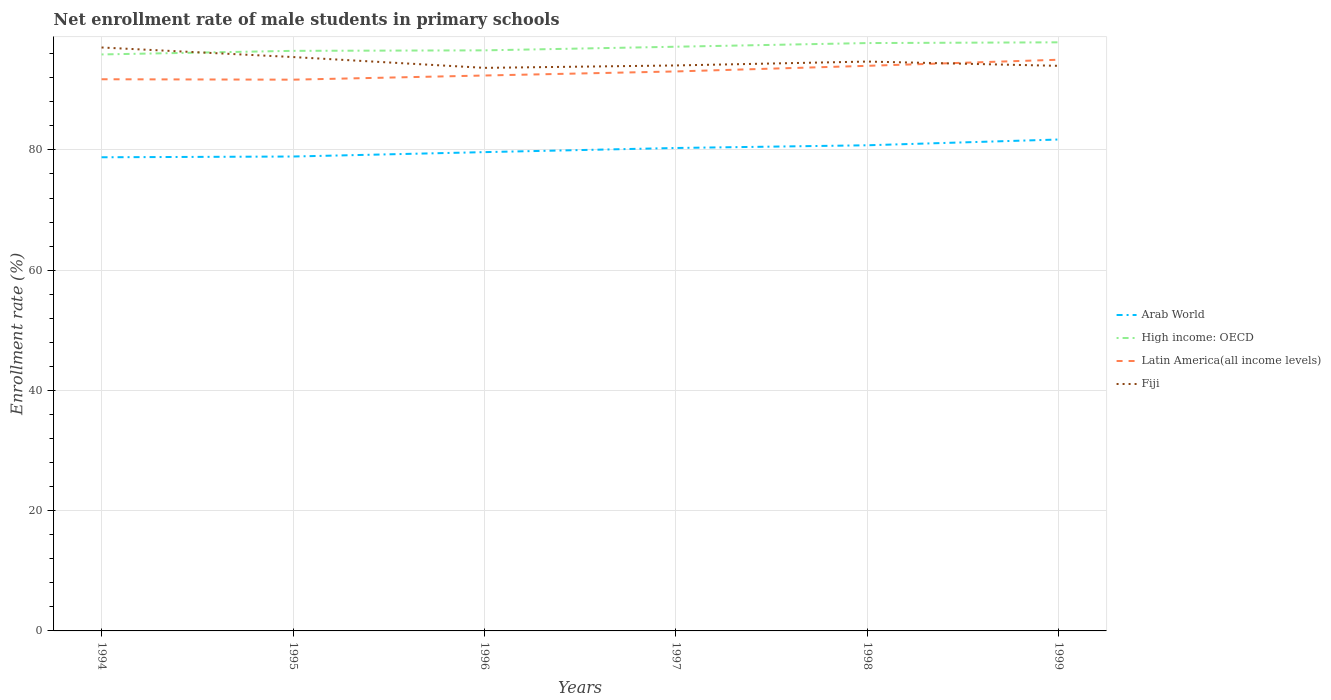How many different coloured lines are there?
Offer a very short reply. 4. Does the line corresponding to Fiji intersect with the line corresponding to High income: OECD?
Give a very brief answer. Yes. Across all years, what is the maximum net enrollment rate of male students in primary schools in High income: OECD?
Your answer should be compact. 95.88. What is the total net enrollment rate of male students in primary schools in High income: OECD in the graph?
Offer a terse response. -0.68. What is the difference between the highest and the second highest net enrollment rate of male students in primary schools in Arab World?
Your answer should be compact. 2.95. What is the difference between the highest and the lowest net enrollment rate of male students in primary schools in Arab World?
Ensure brevity in your answer.  3. Is the net enrollment rate of male students in primary schools in Latin America(all income levels) strictly greater than the net enrollment rate of male students in primary schools in Arab World over the years?
Give a very brief answer. No. How many lines are there?
Your answer should be compact. 4. How many years are there in the graph?
Provide a short and direct response. 6. What is the difference between two consecutive major ticks on the Y-axis?
Offer a terse response. 20. Does the graph contain any zero values?
Your answer should be very brief. No. How many legend labels are there?
Ensure brevity in your answer.  4. How are the legend labels stacked?
Your answer should be very brief. Vertical. What is the title of the graph?
Give a very brief answer. Net enrollment rate of male students in primary schools. Does "Egypt, Arab Rep." appear as one of the legend labels in the graph?
Give a very brief answer. No. What is the label or title of the Y-axis?
Ensure brevity in your answer.  Enrollment rate (%). What is the Enrollment rate (%) in Arab World in 1994?
Offer a terse response. 78.78. What is the Enrollment rate (%) of High income: OECD in 1994?
Your answer should be very brief. 95.88. What is the Enrollment rate (%) in Latin America(all income levels) in 1994?
Give a very brief answer. 91.76. What is the Enrollment rate (%) in Fiji in 1994?
Your answer should be very brief. 97.04. What is the Enrollment rate (%) in Arab World in 1995?
Your response must be concise. 78.91. What is the Enrollment rate (%) of High income: OECD in 1995?
Keep it short and to the point. 96.48. What is the Enrollment rate (%) in Latin America(all income levels) in 1995?
Offer a terse response. 91.69. What is the Enrollment rate (%) in Fiji in 1995?
Offer a very short reply. 95.45. What is the Enrollment rate (%) of Arab World in 1996?
Your answer should be compact. 79.64. What is the Enrollment rate (%) of High income: OECD in 1996?
Provide a succinct answer. 96.56. What is the Enrollment rate (%) of Latin America(all income levels) in 1996?
Keep it short and to the point. 92.38. What is the Enrollment rate (%) in Fiji in 1996?
Your answer should be very brief. 93.65. What is the Enrollment rate (%) of Arab World in 1997?
Offer a terse response. 80.33. What is the Enrollment rate (%) in High income: OECD in 1997?
Offer a terse response. 97.17. What is the Enrollment rate (%) in Latin America(all income levels) in 1997?
Your answer should be very brief. 93.06. What is the Enrollment rate (%) of Fiji in 1997?
Ensure brevity in your answer.  94.05. What is the Enrollment rate (%) in Arab World in 1998?
Your answer should be compact. 80.78. What is the Enrollment rate (%) in High income: OECD in 1998?
Make the answer very short. 97.78. What is the Enrollment rate (%) in Latin America(all income levels) in 1998?
Offer a terse response. 93.99. What is the Enrollment rate (%) in Fiji in 1998?
Keep it short and to the point. 94.7. What is the Enrollment rate (%) in Arab World in 1999?
Give a very brief answer. 81.74. What is the Enrollment rate (%) in High income: OECD in 1999?
Provide a succinct answer. 97.9. What is the Enrollment rate (%) of Latin America(all income levels) in 1999?
Give a very brief answer. 95. What is the Enrollment rate (%) of Fiji in 1999?
Give a very brief answer. 93.99. Across all years, what is the maximum Enrollment rate (%) in Arab World?
Give a very brief answer. 81.74. Across all years, what is the maximum Enrollment rate (%) in High income: OECD?
Your answer should be compact. 97.9. Across all years, what is the maximum Enrollment rate (%) in Latin America(all income levels)?
Offer a very short reply. 95. Across all years, what is the maximum Enrollment rate (%) in Fiji?
Ensure brevity in your answer.  97.04. Across all years, what is the minimum Enrollment rate (%) in Arab World?
Ensure brevity in your answer.  78.78. Across all years, what is the minimum Enrollment rate (%) of High income: OECD?
Offer a terse response. 95.88. Across all years, what is the minimum Enrollment rate (%) of Latin America(all income levels)?
Offer a terse response. 91.69. Across all years, what is the minimum Enrollment rate (%) in Fiji?
Keep it short and to the point. 93.65. What is the total Enrollment rate (%) in Arab World in the graph?
Your response must be concise. 480.16. What is the total Enrollment rate (%) of High income: OECD in the graph?
Your answer should be compact. 581.78. What is the total Enrollment rate (%) of Latin America(all income levels) in the graph?
Provide a succinct answer. 557.88. What is the total Enrollment rate (%) in Fiji in the graph?
Provide a short and direct response. 568.89. What is the difference between the Enrollment rate (%) of Arab World in 1994 and that in 1995?
Keep it short and to the point. -0.12. What is the difference between the Enrollment rate (%) of High income: OECD in 1994 and that in 1995?
Offer a terse response. -0.6. What is the difference between the Enrollment rate (%) in Latin America(all income levels) in 1994 and that in 1995?
Provide a short and direct response. 0.07. What is the difference between the Enrollment rate (%) of Fiji in 1994 and that in 1995?
Keep it short and to the point. 1.59. What is the difference between the Enrollment rate (%) of Arab World in 1994 and that in 1996?
Your answer should be very brief. -0.85. What is the difference between the Enrollment rate (%) of High income: OECD in 1994 and that in 1996?
Your response must be concise. -0.68. What is the difference between the Enrollment rate (%) in Latin America(all income levels) in 1994 and that in 1996?
Your answer should be very brief. -0.62. What is the difference between the Enrollment rate (%) of Fiji in 1994 and that in 1996?
Offer a very short reply. 3.39. What is the difference between the Enrollment rate (%) of Arab World in 1994 and that in 1997?
Offer a terse response. -1.54. What is the difference between the Enrollment rate (%) in High income: OECD in 1994 and that in 1997?
Give a very brief answer. -1.28. What is the difference between the Enrollment rate (%) in Latin America(all income levels) in 1994 and that in 1997?
Give a very brief answer. -1.3. What is the difference between the Enrollment rate (%) in Fiji in 1994 and that in 1997?
Provide a short and direct response. 2.99. What is the difference between the Enrollment rate (%) of Arab World in 1994 and that in 1998?
Provide a succinct answer. -1.99. What is the difference between the Enrollment rate (%) of High income: OECD in 1994 and that in 1998?
Provide a short and direct response. -1.89. What is the difference between the Enrollment rate (%) of Latin America(all income levels) in 1994 and that in 1998?
Make the answer very short. -2.23. What is the difference between the Enrollment rate (%) of Fiji in 1994 and that in 1998?
Your answer should be very brief. 2.34. What is the difference between the Enrollment rate (%) of Arab World in 1994 and that in 1999?
Provide a short and direct response. -2.95. What is the difference between the Enrollment rate (%) of High income: OECD in 1994 and that in 1999?
Your response must be concise. -2.02. What is the difference between the Enrollment rate (%) of Latin America(all income levels) in 1994 and that in 1999?
Keep it short and to the point. -3.25. What is the difference between the Enrollment rate (%) of Fiji in 1994 and that in 1999?
Make the answer very short. 3.05. What is the difference between the Enrollment rate (%) in Arab World in 1995 and that in 1996?
Keep it short and to the point. -0.73. What is the difference between the Enrollment rate (%) in High income: OECD in 1995 and that in 1996?
Provide a short and direct response. -0.08. What is the difference between the Enrollment rate (%) of Latin America(all income levels) in 1995 and that in 1996?
Your answer should be compact. -0.69. What is the difference between the Enrollment rate (%) of Fiji in 1995 and that in 1996?
Your answer should be compact. 1.8. What is the difference between the Enrollment rate (%) in Arab World in 1995 and that in 1997?
Provide a succinct answer. -1.42. What is the difference between the Enrollment rate (%) of High income: OECD in 1995 and that in 1997?
Offer a very short reply. -0.68. What is the difference between the Enrollment rate (%) in Latin America(all income levels) in 1995 and that in 1997?
Ensure brevity in your answer.  -1.37. What is the difference between the Enrollment rate (%) of Fiji in 1995 and that in 1997?
Offer a very short reply. 1.4. What is the difference between the Enrollment rate (%) of Arab World in 1995 and that in 1998?
Keep it short and to the point. -1.87. What is the difference between the Enrollment rate (%) in High income: OECD in 1995 and that in 1998?
Your answer should be compact. -1.29. What is the difference between the Enrollment rate (%) in Latin America(all income levels) in 1995 and that in 1998?
Your answer should be compact. -2.3. What is the difference between the Enrollment rate (%) in Fiji in 1995 and that in 1998?
Give a very brief answer. 0.75. What is the difference between the Enrollment rate (%) in Arab World in 1995 and that in 1999?
Ensure brevity in your answer.  -2.83. What is the difference between the Enrollment rate (%) in High income: OECD in 1995 and that in 1999?
Provide a short and direct response. -1.42. What is the difference between the Enrollment rate (%) in Latin America(all income levels) in 1995 and that in 1999?
Make the answer very short. -3.32. What is the difference between the Enrollment rate (%) of Fiji in 1995 and that in 1999?
Ensure brevity in your answer.  1.46. What is the difference between the Enrollment rate (%) of Arab World in 1996 and that in 1997?
Your response must be concise. -0.69. What is the difference between the Enrollment rate (%) of High income: OECD in 1996 and that in 1997?
Ensure brevity in your answer.  -0.6. What is the difference between the Enrollment rate (%) in Latin America(all income levels) in 1996 and that in 1997?
Keep it short and to the point. -0.68. What is the difference between the Enrollment rate (%) in Fiji in 1996 and that in 1997?
Offer a terse response. -0.4. What is the difference between the Enrollment rate (%) of Arab World in 1996 and that in 1998?
Provide a short and direct response. -1.14. What is the difference between the Enrollment rate (%) of High income: OECD in 1996 and that in 1998?
Give a very brief answer. -1.21. What is the difference between the Enrollment rate (%) of Latin America(all income levels) in 1996 and that in 1998?
Keep it short and to the point. -1.61. What is the difference between the Enrollment rate (%) of Fiji in 1996 and that in 1998?
Your answer should be very brief. -1.05. What is the difference between the Enrollment rate (%) of Arab World in 1996 and that in 1999?
Offer a very short reply. -2.1. What is the difference between the Enrollment rate (%) of High income: OECD in 1996 and that in 1999?
Your answer should be compact. -1.34. What is the difference between the Enrollment rate (%) of Latin America(all income levels) in 1996 and that in 1999?
Offer a very short reply. -2.62. What is the difference between the Enrollment rate (%) in Fiji in 1996 and that in 1999?
Offer a terse response. -0.34. What is the difference between the Enrollment rate (%) in Arab World in 1997 and that in 1998?
Make the answer very short. -0.45. What is the difference between the Enrollment rate (%) of High income: OECD in 1997 and that in 1998?
Ensure brevity in your answer.  -0.61. What is the difference between the Enrollment rate (%) in Latin America(all income levels) in 1997 and that in 1998?
Offer a very short reply. -0.93. What is the difference between the Enrollment rate (%) in Fiji in 1997 and that in 1998?
Keep it short and to the point. -0.65. What is the difference between the Enrollment rate (%) of Arab World in 1997 and that in 1999?
Provide a short and direct response. -1.41. What is the difference between the Enrollment rate (%) in High income: OECD in 1997 and that in 1999?
Your answer should be compact. -0.73. What is the difference between the Enrollment rate (%) of Latin America(all income levels) in 1997 and that in 1999?
Provide a succinct answer. -1.95. What is the difference between the Enrollment rate (%) of Fiji in 1997 and that in 1999?
Keep it short and to the point. 0.07. What is the difference between the Enrollment rate (%) in Arab World in 1998 and that in 1999?
Offer a very short reply. -0.96. What is the difference between the Enrollment rate (%) of High income: OECD in 1998 and that in 1999?
Provide a short and direct response. -0.12. What is the difference between the Enrollment rate (%) of Latin America(all income levels) in 1998 and that in 1999?
Give a very brief answer. -1.01. What is the difference between the Enrollment rate (%) in Fiji in 1998 and that in 1999?
Provide a succinct answer. 0.71. What is the difference between the Enrollment rate (%) in Arab World in 1994 and the Enrollment rate (%) in High income: OECD in 1995?
Give a very brief answer. -17.7. What is the difference between the Enrollment rate (%) in Arab World in 1994 and the Enrollment rate (%) in Latin America(all income levels) in 1995?
Your response must be concise. -12.91. What is the difference between the Enrollment rate (%) of Arab World in 1994 and the Enrollment rate (%) of Fiji in 1995?
Your response must be concise. -16.67. What is the difference between the Enrollment rate (%) in High income: OECD in 1994 and the Enrollment rate (%) in Latin America(all income levels) in 1995?
Your answer should be very brief. 4.2. What is the difference between the Enrollment rate (%) in High income: OECD in 1994 and the Enrollment rate (%) in Fiji in 1995?
Give a very brief answer. 0.43. What is the difference between the Enrollment rate (%) of Latin America(all income levels) in 1994 and the Enrollment rate (%) of Fiji in 1995?
Offer a very short reply. -3.69. What is the difference between the Enrollment rate (%) of Arab World in 1994 and the Enrollment rate (%) of High income: OECD in 1996?
Keep it short and to the point. -17.78. What is the difference between the Enrollment rate (%) of Arab World in 1994 and the Enrollment rate (%) of Latin America(all income levels) in 1996?
Make the answer very short. -13.6. What is the difference between the Enrollment rate (%) in Arab World in 1994 and the Enrollment rate (%) in Fiji in 1996?
Give a very brief answer. -14.87. What is the difference between the Enrollment rate (%) in High income: OECD in 1994 and the Enrollment rate (%) in Latin America(all income levels) in 1996?
Your answer should be very brief. 3.5. What is the difference between the Enrollment rate (%) of High income: OECD in 1994 and the Enrollment rate (%) of Fiji in 1996?
Keep it short and to the point. 2.23. What is the difference between the Enrollment rate (%) in Latin America(all income levels) in 1994 and the Enrollment rate (%) in Fiji in 1996?
Ensure brevity in your answer.  -1.9. What is the difference between the Enrollment rate (%) in Arab World in 1994 and the Enrollment rate (%) in High income: OECD in 1997?
Ensure brevity in your answer.  -18.39. What is the difference between the Enrollment rate (%) of Arab World in 1994 and the Enrollment rate (%) of Latin America(all income levels) in 1997?
Your response must be concise. -14.28. What is the difference between the Enrollment rate (%) in Arab World in 1994 and the Enrollment rate (%) in Fiji in 1997?
Offer a terse response. -15.27. What is the difference between the Enrollment rate (%) in High income: OECD in 1994 and the Enrollment rate (%) in Latin America(all income levels) in 1997?
Ensure brevity in your answer.  2.83. What is the difference between the Enrollment rate (%) of High income: OECD in 1994 and the Enrollment rate (%) of Fiji in 1997?
Make the answer very short. 1.83. What is the difference between the Enrollment rate (%) in Latin America(all income levels) in 1994 and the Enrollment rate (%) in Fiji in 1997?
Offer a very short reply. -2.3. What is the difference between the Enrollment rate (%) in Arab World in 1994 and the Enrollment rate (%) in High income: OECD in 1998?
Make the answer very short. -18.99. What is the difference between the Enrollment rate (%) in Arab World in 1994 and the Enrollment rate (%) in Latin America(all income levels) in 1998?
Provide a succinct answer. -15.21. What is the difference between the Enrollment rate (%) in Arab World in 1994 and the Enrollment rate (%) in Fiji in 1998?
Provide a short and direct response. -15.92. What is the difference between the Enrollment rate (%) of High income: OECD in 1994 and the Enrollment rate (%) of Latin America(all income levels) in 1998?
Offer a very short reply. 1.89. What is the difference between the Enrollment rate (%) in High income: OECD in 1994 and the Enrollment rate (%) in Fiji in 1998?
Your response must be concise. 1.18. What is the difference between the Enrollment rate (%) in Latin America(all income levels) in 1994 and the Enrollment rate (%) in Fiji in 1998?
Keep it short and to the point. -2.94. What is the difference between the Enrollment rate (%) of Arab World in 1994 and the Enrollment rate (%) of High income: OECD in 1999?
Provide a short and direct response. -19.12. What is the difference between the Enrollment rate (%) of Arab World in 1994 and the Enrollment rate (%) of Latin America(all income levels) in 1999?
Provide a succinct answer. -16.22. What is the difference between the Enrollment rate (%) of Arab World in 1994 and the Enrollment rate (%) of Fiji in 1999?
Give a very brief answer. -15.21. What is the difference between the Enrollment rate (%) of High income: OECD in 1994 and the Enrollment rate (%) of Latin America(all income levels) in 1999?
Provide a succinct answer. 0.88. What is the difference between the Enrollment rate (%) in High income: OECD in 1994 and the Enrollment rate (%) in Fiji in 1999?
Your response must be concise. 1.9. What is the difference between the Enrollment rate (%) in Latin America(all income levels) in 1994 and the Enrollment rate (%) in Fiji in 1999?
Your response must be concise. -2.23. What is the difference between the Enrollment rate (%) of Arab World in 1995 and the Enrollment rate (%) of High income: OECD in 1996?
Your answer should be compact. -17.66. What is the difference between the Enrollment rate (%) of Arab World in 1995 and the Enrollment rate (%) of Latin America(all income levels) in 1996?
Offer a terse response. -13.47. What is the difference between the Enrollment rate (%) of Arab World in 1995 and the Enrollment rate (%) of Fiji in 1996?
Your response must be concise. -14.75. What is the difference between the Enrollment rate (%) in High income: OECD in 1995 and the Enrollment rate (%) in Latin America(all income levels) in 1996?
Provide a short and direct response. 4.1. What is the difference between the Enrollment rate (%) of High income: OECD in 1995 and the Enrollment rate (%) of Fiji in 1996?
Your answer should be very brief. 2.83. What is the difference between the Enrollment rate (%) in Latin America(all income levels) in 1995 and the Enrollment rate (%) in Fiji in 1996?
Offer a terse response. -1.96. What is the difference between the Enrollment rate (%) in Arab World in 1995 and the Enrollment rate (%) in High income: OECD in 1997?
Give a very brief answer. -18.26. What is the difference between the Enrollment rate (%) in Arab World in 1995 and the Enrollment rate (%) in Latin America(all income levels) in 1997?
Your answer should be very brief. -14.15. What is the difference between the Enrollment rate (%) in Arab World in 1995 and the Enrollment rate (%) in Fiji in 1997?
Your response must be concise. -15.15. What is the difference between the Enrollment rate (%) of High income: OECD in 1995 and the Enrollment rate (%) of Latin America(all income levels) in 1997?
Your response must be concise. 3.43. What is the difference between the Enrollment rate (%) of High income: OECD in 1995 and the Enrollment rate (%) of Fiji in 1997?
Your answer should be compact. 2.43. What is the difference between the Enrollment rate (%) of Latin America(all income levels) in 1995 and the Enrollment rate (%) of Fiji in 1997?
Provide a succinct answer. -2.36. What is the difference between the Enrollment rate (%) of Arab World in 1995 and the Enrollment rate (%) of High income: OECD in 1998?
Provide a succinct answer. -18.87. What is the difference between the Enrollment rate (%) in Arab World in 1995 and the Enrollment rate (%) in Latin America(all income levels) in 1998?
Make the answer very short. -15.08. What is the difference between the Enrollment rate (%) in Arab World in 1995 and the Enrollment rate (%) in Fiji in 1998?
Offer a very short reply. -15.79. What is the difference between the Enrollment rate (%) of High income: OECD in 1995 and the Enrollment rate (%) of Latin America(all income levels) in 1998?
Give a very brief answer. 2.49. What is the difference between the Enrollment rate (%) in High income: OECD in 1995 and the Enrollment rate (%) in Fiji in 1998?
Provide a succinct answer. 1.78. What is the difference between the Enrollment rate (%) in Latin America(all income levels) in 1995 and the Enrollment rate (%) in Fiji in 1998?
Ensure brevity in your answer.  -3.01. What is the difference between the Enrollment rate (%) in Arab World in 1995 and the Enrollment rate (%) in High income: OECD in 1999?
Provide a succinct answer. -18.99. What is the difference between the Enrollment rate (%) of Arab World in 1995 and the Enrollment rate (%) of Latin America(all income levels) in 1999?
Your answer should be very brief. -16.1. What is the difference between the Enrollment rate (%) in Arab World in 1995 and the Enrollment rate (%) in Fiji in 1999?
Offer a terse response. -15.08. What is the difference between the Enrollment rate (%) in High income: OECD in 1995 and the Enrollment rate (%) in Latin America(all income levels) in 1999?
Ensure brevity in your answer.  1.48. What is the difference between the Enrollment rate (%) in High income: OECD in 1995 and the Enrollment rate (%) in Fiji in 1999?
Offer a terse response. 2.5. What is the difference between the Enrollment rate (%) of Latin America(all income levels) in 1995 and the Enrollment rate (%) of Fiji in 1999?
Make the answer very short. -2.3. What is the difference between the Enrollment rate (%) in Arab World in 1996 and the Enrollment rate (%) in High income: OECD in 1997?
Your answer should be compact. -17.53. What is the difference between the Enrollment rate (%) of Arab World in 1996 and the Enrollment rate (%) of Latin America(all income levels) in 1997?
Ensure brevity in your answer.  -13.42. What is the difference between the Enrollment rate (%) of Arab World in 1996 and the Enrollment rate (%) of Fiji in 1997?
Your response must be concise. -14.42. What is the difference between the Enrollment rate (%) of High income: OECD in 1996 and the Enrollment rate (%) of Latin America(all income levels) in 1997?
Keep it short and to the point. 3.51. What is the difference between the Enrollment rate (%) in High income: OECD in 1996 and the Enrollment rate (%) in Fiji in 1997?
Ensure brevity in your answer.  2.51. What is the difference between the Enrollment rate (%) of Latin America(all income levels) in 1996 and the Enrollment rate (%) of Fiji in 1997?
Provide a succinct answer. -1.67. What is the difference between the Enrollment rate (%) in Arab World in 1996 and the Enrollment rate (%) in High income: OECD in 1998?
Ensure brevity in your answer.  -18.14. What is the difference between the Enrollment rate (%) of Arab World in 1996 and the Enrollment rate (%) of Latin America(all income levels) in 1998?
Your answer should be very brief. -14.35. What is the difference between the Enrollment rate (%) of Arab World in 1996 and the Enrollment rate (%) of Fiji in 1998?
Offer a terse response. -15.06. What is the difference between the Enrollment rate (%) of High income: OECD in 1996 and the Enrollment rate (%) of Latin America(all income levels) in 1998?
Provide a short and direct response. 2.57. What is the difference between the Enrollment rate (%) in High income: OECD in 1996 and the Enrollment rate (%) in Fiji in 1998?
Your answer should be very brief. 1.86. What is the difference between the Enrollment rate (%) in Latin America(all income levels) in 1996 and the Enrollment rate (%) in Fiji in 1998?
Your response must be concise. -2.32. What is the difference between the Enrollment rate (%) of Arab World in 1996 and the Enrollment rate (%) of High income: OECD in 1999?
Provide a succinct answer. -18.26. What is the difference between the Enrollment rate (%) in Arab World in 1996 and the Enrollment rate (%) in Latin America(all income levels) in 1999?
Offer a very short reply. -15.37. What is the difference between the Enrollment rate (%) of Arab World in 1996 and the Enrollment rate (%) of Fiji in 1999?
Offer a terse response. -14.35. What is the difference between the Enrollment rate (%) in High income: OECD in 1996 and the Enrollment rate (%) in Latin America(all income levels) in 1999?
Your answer should be very brief. 1.56. What is the difference between the Enrollment rate (%) in High income: OECD in 1996 and the Enrollment rate (%) in Fiji in 1999?
Ensure brevity in your answer.  2.58. What is the difference between the Enrollment rate (%) of Latin America(all income levels) in 1996 and the Enrollment rate (%) of Fiji in 1999?
Provide a short and direct response. -1.61. What is the difference between the Enrollment rate (%) in Arab World in 1997 and the Enrollment rate (%) in High income: OECD in 1998?
Provide a short and direct response. -17.45. What is the difference between the Enrollment rate (%) of Arab World in 1997 and the Enrollment rate (%) of Latin America(all income levels) in 1998?
Offer a terse response. -13.67. What is the difference between the Enrollment rate (%) of Arab World in 1997 and the Enrollment rate (%) of Fiji in 1998?
Provide a short and direct response. -14.37. What is the difference between the Enrollment rate (%) in High income: OECD in 1997 and the Enrollment rate (%) in Latin America(all income levels) in 1998?
Offer a very short reply. 3.18. What is the difference between the Enrollment rate (%) of High income: OECD in 1997 and the Enrollment rate (%) of Fiji in 1998?
Ensure brevity in your answer.  2.47. What is the difference between the Enrollment rate (%) of Latin America(all income levels) in 1997 and the Enrollment rate (%) of Fiji in 1998?
Give a very brief answer. -1.64. What is the difference between the Enrollment rate (%) in Arab World in 1997 and the Enrollment rate (%) in High income: OECD in 1999?
Your answer should be compact. -17.57. What is the difference between the Enrollment rate (%) of Arab World in 1997 and the Enrollment rate (%) of Latin America(all income levels) in 1999?
Your response must be concise. -14.68. What is the difference between the Enrollment rate (%) in Arab World in 1997 and the Enrollment rate (%) in Fiji in 1999?
Provide a short and direct response. -13.66. What is the difference between the Enrollment rate (%) in High income: OECD in 1997 and the Enrollment rate (%) in Latin America(all income levels) in 1999?
Give a very brief answer. 2.16. What is the difference between the Enrollment rate (%) of High income: OECD in 1997 and the Enrollment rate (%) of Fiji in 1999?
Provide a succinct answer. 3.18. What is the difference between the Enrollment rate (%) of Latin America(all income levels) in 1997 and the Enrollment rate (%) of Fiji in 1999?
Provide a succinct answer. -0.93. What is the difference between the Enrollment rate (%) in Arab World in 1998 and the Enrollment rate (%) in High income: OECD in 1999?
Your response must be concise. -17.12. What is the difference between the Enrollment rate (%) in Arab World in 1998 and the Enrollment rate (%) in Latin America(all income levels) in 1999?
Provide a short and direct response. -14.23. What is the difference between the Enrollment rate (%) in Arab World in 1998 and the Enrollment rate (%) in Fiji in 1999?
Give a very brief answer. -13.21. What is the difference between the Enrollment rate (%) in High income: OECD in 1998 and the Enrollment rate (%) in Latin America(all income levels) in 1999?
Give a very brief answer. 2.77. What is the difference between the Enrollment rate (%) of High income: OECD in 1998 and the Enrollment rate (%) of Fiji in 1999?
Your answer should be very brief. 3.79. What is the difference between the Enrollment rate (%) of Latin America(all income levels) in 1998 and the Enrollment rate (%) of Fiji in 1999?
Offer a terse response. 0. What is the average Enrollment rate (%) of Arab World per year?
Make the answer very short. 80.03. What is the average Enrollment rate (%) of High income: OECD per year?
Offer a very short reply. 96.96. What is the average Enrollment rate (%) of Latin America(all income levels) per year?
Give a very brief answer. 92.98. What is the average Enrollment rate (%) in Fiji per year?
Ensure brevity in your answer.  94.81. In the year 1994, what is the difference between the Enrollment rate (%) in Arab World and Enrollment rate (%) in High income: OECD?
Your answer should be compact. -17.1. In the year 1994, what is the difference between the Enrollment rate (%) in Arab World and Enrollment rate (%) in Latin America(all income levels)?
Your answer should be very brief. -12.98. In the year 1994, what is the difference between the Enrollment rate (%) in Arab World and Enrollment rate (%) in Fiji?
Provide a succinct answer. -18.26. In the year 1994, what is the difference between the Enrollment rate (%) in High income: OECD and Enrollment rate (%) in Latin America(all income levels)?
Provide a succinct answer. 4.13. In the year 1994, what is the difference between the Enrollment rate (%) of High income: OECD and Enrollment rate (%) of Fiji?
Ensure brevity in your answer.  -1.16. In the year 1994, what is the difference between the Enrollment rate (%) of Latin America(all income levels) and Enrollment rate (%) of Fiji?
Your answer should be very brief. -5.28. In the year 1995, what is the difference between the Enrollment rate (%) of Arab World and Enrollment rate (%) of High income: OECD?
Keep it short and to the point. -17.58. In the year 1995, what is the difference between the Enrollment rate (%) of Arab World and Enrollment rate (%) of Latin America(all income levels)?
Provide a succinct answer. -12.78. In the year 1995, what is the difference between the Enrollment rate (%) of Arab World and Enrollment rate (%) of Fiji?
Provide a succinct answer. -16.54. In the year 1995, what is the difference between the Enrollment rate (%) of High income: OECD and Enrollment rate (%) of Latin America(all income levels)?
Your answer should be very brief. 4.79. In the year 1995, what is the difference between the Enrollment rate (%) of High income: OECD and Enrollment rate (%) of Fiji?
Your answer should be very brief. 1.03. In the year 1995, what is the difference between the Enrollment rate (%) in Latin America(all income levels) and Enrollment rate (%) in Fiji?
Your answer should be compact. -3.76. In the year 1996, what is the difference between the Enrollment rate (%) in Arab World and Enrollment rate (%) in High income: OECD?
Make the answer very short. -16.93. In the year 1996, what is the difference between the Enrollment rate (%) in Arab World and Enrollment rate (%) in Latin America(all income levels)?
Offer a terse response. -12.74. In the year 1996, what is the difference between the Enrollment rate (%) of Arab World and Enrollment rate (%) of Fiji?
Offer a very short reply. -14.02. In the year 1996, what is the difference between the Enrollment rate (%) of High income: OECD and Enrollment rate (%) of Latin America(all income levels)?
Your answer should be very brief. 4.18. In the year 1996, what is the difference between the Enrollment rate (%) of High income: OECD and Enrollment rate (%) of Fiji?
Offer a very short reply. 2.91. In the year 1996, what is the difference between the Enrollment rate (%) in Latin America(all income levels) and Enrollment rate (%) in Fiji?
Your answer should be compact. -1.27. In the year 1997, what is the difference between the Enrollment rate (%) in Arab World and Enrollment rate (%) in High income: OECD?
Your response must be concise. -16.84. In the year 1997, what is the difference between the Enrollment rate (%) of Arab World and Enrollment rate (%) of Latin America(all income levels)?
Make the answer very short. -12.73. In the year 1997, what is the difference between the Enrollment rate (%) in Arab World and Enrollment rate (%) in Fiji?
Give a very brief answer. -13.73. In the year 1997, what is the difference between the Enrollment rate (%) of High income: OECD and Enrollment rate (%) of Latin America(all income levels)?
Offer a very short reply. 4.11. In the year 1997, what is the difference between the Enrollment rate (%) of High income: OECD and Enrollment rate (%) of Fiji?
Your answer should be compact. 3.11. In the year 1997, what is the difference between the Enrollment rate (%) in Latin America(all income levels) and Enrollment rate (%) in Fiji?
Offer a very short reply. -1. In the year 1998, what is the difference between the Enrollment rate (%) in Arab World and Enrollment rate (%) in High income: OECD?
Ensure brevity in your answer.  -17. In the year 1998, what is the difference between the Enrollment rate (%) in Arab World and Enrollment rate (%) in Latin America(all income levels)?
Make the answer very short. -13.22. In the year 1998, what is the difference between the Enrollment rate (%) in Arab World and Enrollment rate (%) in Fiji?
Provide a short and direct response. -13.92. In the year 1998, what is the difference between the Enrollment rate (%) in High income: OECD and Enrollment rate (%) in Latin America(all income levels)?
Provide a succinct answer. 3.79. In the year 1998, what is the difference between the Enrollment rate (%) of High income: OECD and Enrollment rate (%) of Fiji?
Offer a terse response. 3.08. In the year 1998, what is the difference between the Enrollment rate (%) in Latin America(all income levels) and Enrollment rate (%) in Fiji?
Offer a very short reply. -0.71. In the year 1999, what is the difference between the Enrollment rate (%) of Arab World and Enrollment rate (%) of High income: OECD?
Offer a very short reply. -16.16. In the year 1999, what is the difference between the Enrollment rate (%) in Arab World and Enrollment rate (%) in Latin America(all income levels)?
Provide a short and direct response. -13.27. In the year 1999, what is the difference between the Enrollment rate (%) of Arab World and Enrollment rate (%) of Fiji?
Your answer should be compact. -12.25. In the year 1999, what is the difference between the Enrollment rate (%) in High income: OECD and Enrollment rate (%) in Latin America(all income levels)?
Provide a succinct answer. 2.9. In the year 1999, what is the difference between the Enrollment rate (%) in High income: OECD and Enrollment rate (%) in Fiji?
Provide a succinct answer. 3.91. In the year 1999, what is the difference between the Enrollment rate (%) of Latin America(all income levels) and Enrollment rate (%) of Fiji?
Your response must be concise. 1.02. What is the ratio of the Enrollment rate (%) in Latin America(all income levels) in 1994 to that in 1995?
Your answer should be very brief. 1. What is the ratio of the Enrollment rate (%) in Fiji in 1994 to that in 1995?
Your answer should be compact. 1.02. What is the ratio of the Enrollment rate (%) in Arab World in 1994 to that in 1996?
Give a very brief answer. 0.99. What is the ratio of the Enrollment rate (%) of High income: OECD in 1994 to that in 1996?
Your response must be concise. 0.99. What is the ratio of the Enrollment rate (%) in Latin America(all income levels) in 1994 to that in 1996?
Offer a very short reply. 0.99. What is the ratio of the Enrollment rate (%) of Fiji in 1994 to that in 1996?
Make the answer very short. 1.04. What is the ratio of the Enrollment rate (%) of Arab World in 1994 to that in 1997?
Provide a succinct answer. 0.98. What is the ratio of the Enrollment rate (%) of Latin America(all income levels) in 1994 to that in 1997?
Provide a succinct answer. 0.99. What is the ratio of the Enrollment rate (%) in Fiji in 1994 to that in 1997?
Your answer should be compact. 1.03. What is the ratio of the Enrollment rate (%) of Arab World in 1994 to that in 1998?
Make the answer very short. 0.98. What is the ratio of the Enrollment rate (%) in High income: OECD in 1994 to that in 1998?
Provide a short and direct response. 0.98. What is the ratio of the Enrollment rate (%) of Latin America(all income levels) in 1994 to that in 1998?
Provide a short and direct response. 0.98. What is the ratio of the Enrollment rate (%) of Fiji in 1994 to that in 1998?
Offer a very short reply. 1.02. What is the ratio of the Enrollment rate (%) in Arab World in 1994 to that in 1999?
Ensure brevity in your answer.  0.96. What is the ratio of the Enrollment rate (%) of High income: OECD in 1994 to that in 1999?
Your answer should be compact. 0.98. What is the ratio of the Enrollment rate (%) in Latin America(all income levels) in 1994 to that in 1999?
Ensure brevity in your answer.  0.97. What is the ratio of the Enrollment rate (%) in Fiji in 1994 to that in 1999?
Your response must be concise. 1.03. What is the ratio of the Enrollment rate (%) of Arab World in 1995 to that in 1996?
Keep it short and to the point. 0.99. What is the ratio of the Enrollment rate (%) of High income: OECD in 1995 to that in 1996?
Keep it short and to the point. 1. What is the ratio of the Enrollment rate (%) in Latin America(all income levels) in 1995 to that in 1996?
Your response must be concise. 0.99. What is the ratio of the Enrollment rate (%) of Fiji in 1995 to that in 1996?
Offer a terse response. 1.02. What is the ratio of the Enrollment rate (%) of Arab World in 1995 to that in 1997?
Ensure brevity in your answer.  0.98. What is the ratio of the Enrollment rate (%) of High income: OECD in 1995 to that in 1997?
Keep it short and to the point. 0.99. What is the ratio of the Enrollment rate (%) of Fiji in 1995 to that in 1997?
Your response must be concise. 1.01. What is the ratio of the Enrollment rate (%) of Arab World in 1995 to that in 1998?
Make the answer very short. 0.98. What is the ratio of the Enrollment rate (%) in High income: OECD in 1995 to that in 1998?
Offer a very short reply. 0.99. What is the ratio of the Enrollment rate (%) in Latin America(all income levels) in 1995 to that in 1998?
Your response must be concise. 0.98. What is the ratio of the Enrollment rate (%) in Fiji in 1995 to that in 1998?
Provide a succinct answer. 1.01. What is the ratio of the Enrollment rate (%) of Arab World in 1995 to that in 1999?
Provide a succinct answer. 0.97. What is the ratio of the Enrollment rate (%) in High income: OECD in 1995 to that in 1999?
Offer a very short reply. 0.99. What is the ratio of the Enrollment rate (%) of Latin America(all income levels) in 1995 to that in 1999?
Offer a very short reply. 0.97. What is the ratio of the Enrollment rate (%) of Fiji in 1995 to that in 1999?
Offer a terse response. 1.02. What is the ratio of the Enrollment rate (%) in Fiji in 1996 to that in 1997?
Your answer should be very brief. 1. What is the ratio of the Enrollment rate (%) of Arab World in 1996 to that in 1998?
Ensure brevity in your answer.  0.99. What is the ratio of the Enrollment rate (%) in High income: OECD in 1996 to that in 1998?
Provide a short and direct response. 0.99. What is the ratio of the Enrollment rate (%) of Latin America(all income levels) in 1996 to that in 1998?
Your answer should be very brief. 0.98. What is the ratio of the Enrollment rate (%) in Fiji in 1996 to that in 1998?
Give a very brief answer. 0.99. What is the ratio of the Enrollment rate (%) in Arab World in 1996 to that in 1999?
Provide a short and direct response. 0.97. What is the ratio of the Enrollment rate (%) in High income: OECD in 1996 to that in 1999?
Your response must be concise. 0.99. What is the ratio of the Enrollment rate (%) in Latin America(all income levels) in 1996 to that in 1999?
Provide a short and direct response. 0.97. What is the ratio of the Enrollment rate (%) in Fiji in 1996 to that in 1999?
Give a very brief answer. 1. What is the ratio of the Enrollment rate (%) in Arab World in 1997 to that in 1998?
Give a very brief answer. 0.99. What is the ratio of the Enrollment rate (%) in Fiji in 1997 to that in 1998?
Provide a short and direct response. 0.99. What is the ratio of the Enrollment rate (%) of Arab World in 1997 to that in 1999?
Keep it short and to the point. 0.98. What is the ratio of the Enrollment rate (%) of Latin America(all income levels) in 1997 to that in 1999?
Make the answer very short. 0.98. What is the ratio of the Enrollment rate (%) in Fiji in 1997 to that in 1999?
Your response must be concise. 1. What is the ratio of the Enrollment rate (%) of Arab World in 1998 to that in 1999?
Your answer should be very brief. 0.99. What is the ratio of the Enrollment rate (%) in Latin America(all income levels) in 1998 to that in 1999?
Your answer should be very brief. 0.99. What is the ratio of the Enrollment rate (%) of Fiji in 1998 to that in 1999?
Ensure brevity in your answer.  1.01. What is the difference between the highest and the second highest Enrollment rate (%) in Arab World?
Your answer should be compact. 0.96. What is the difference between the highest and the second highest Enrollment rate (%) of High income: OECD?
Offer a terse response. 0.12. What is the difference between the highest and the second highest Enrollment rate (%) of Latin America(all income levels)?
Make the answer very short. 1.01. What is the difference between the highest and the second highest Enrollment rate (%) of Fiji?
Make the answer very short. 1.59. What is the difference between the highest and the lowest Enrollment rate (%) of Arab World?
Offer a terse response. 2.95. What is the difference between the highest and the lowest Enrollment rate (%) of High income: OECD?
Your answer should be compact. 2.02. What is the difference between the highest and the lowest Enrollment rate (%) of Latin America(all income levels)?
Give a very brief answer. 3.32. What is the difference between the highest and the lowest Enrollment rate (%) of Fiji?
Keep it short and to the point. 3.39. 